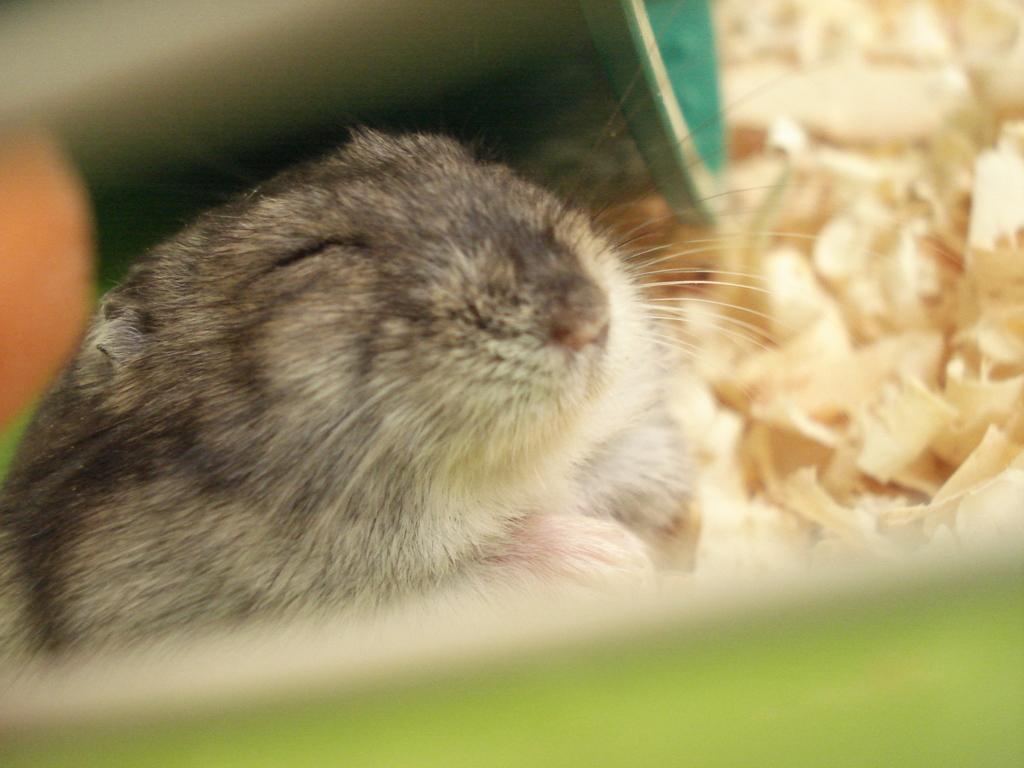Please provide a concise description of this image. In the picture I can see a rat and some other objects. 